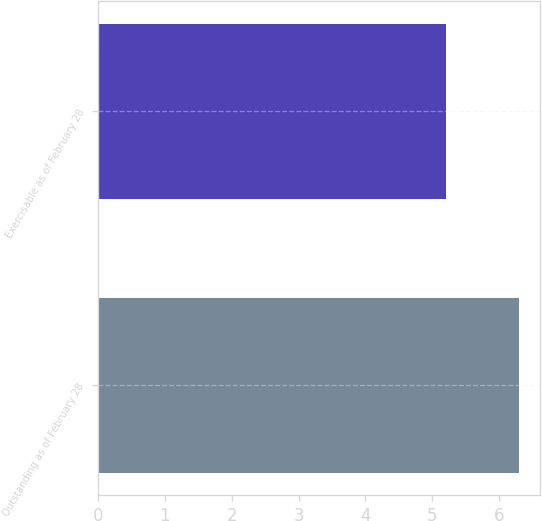<chart> <loc_0><loc_0><loc_500><loc_500><bar_chart><fcel>Outstanding as of February 28<fcel>Exercisable as of February 28<nl><fcel>6.3<fcel>5.2<nl></chart> 